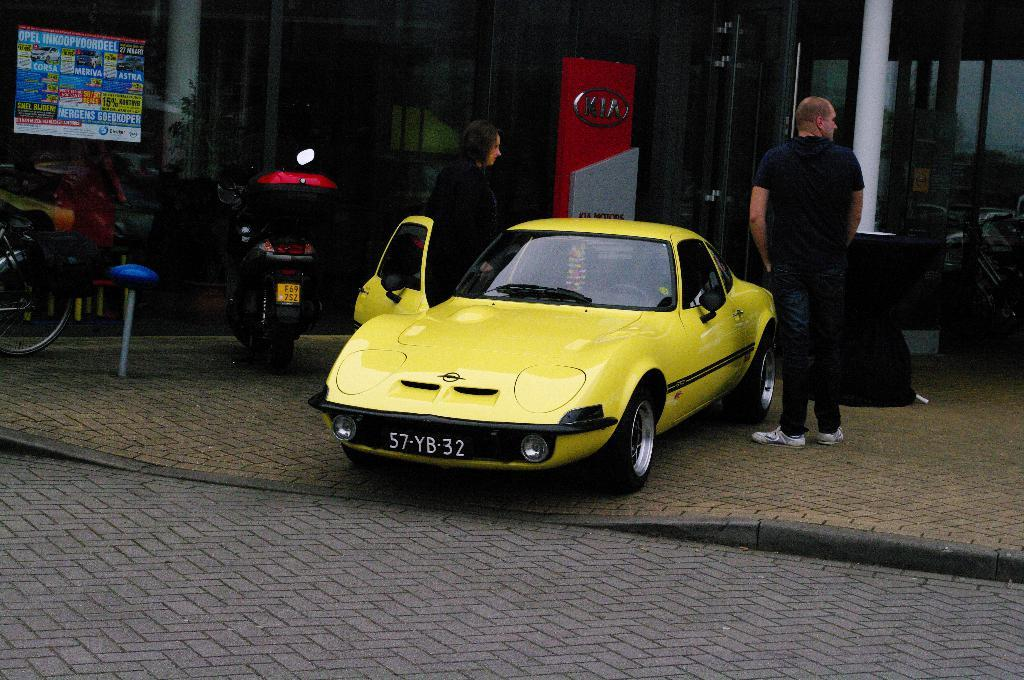<image>
Give a short and clear explanation of the subsequent image. a yellow car that has the number 57 on it 